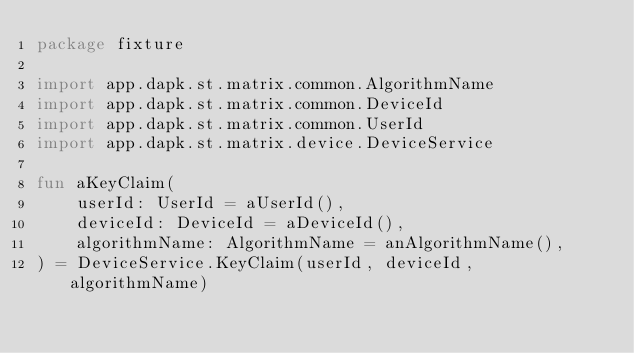Convert code to text. <code><loc_0><loc_0><loc_500><loc_500><_Kotlin_>package fixture

import app.dapk.st.matrix.common.AlgorithmName
import app.dapk.st.matrix.common.DeviceId
import app.dapk.st.matrix.common.UserId
import app.dapk.st.matrix.device.DeviceService

fun aKeyClaim(
    userId: UserId = aUserId(),
    deviceId: DeviceId = aDeviceId(),
    algorithmName: AlgorithmName = anAlgorithmName(),
) = DeviceService.KeyClaim(userId, deviceId, algorithmName)</code> 